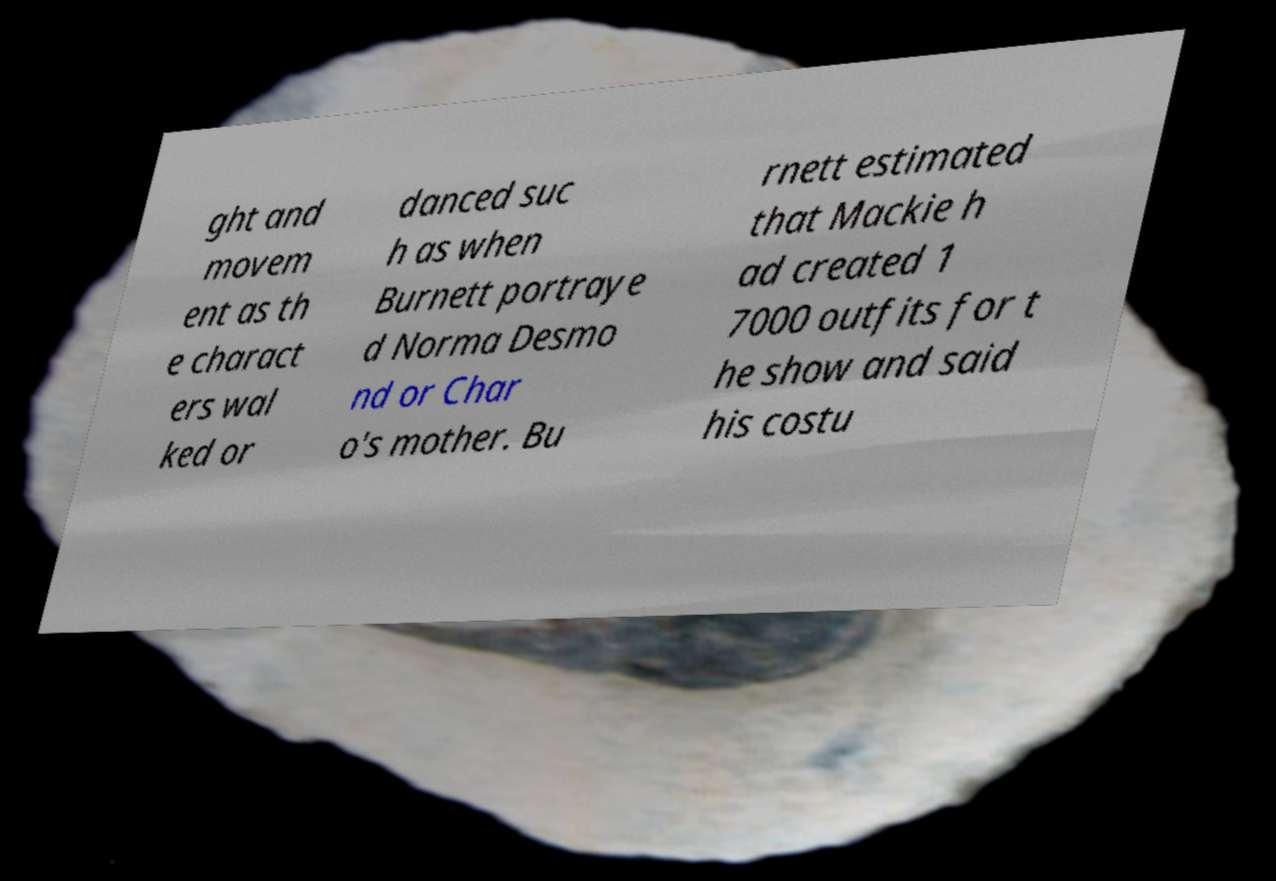I need the written content from this picture converted into text. Can you do that? ght and movem ent as th e charact ers wal ked or danced suc h as when Burnett portraye d Norma Desmo nd or Char o's mother. Bu rnett estimated that Mackie h ad created 1 7000 outfits for t he show and said his costu 